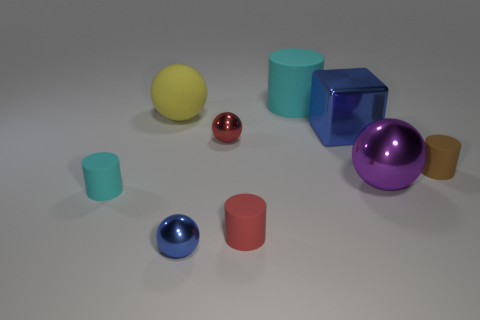Subtract all cylinders. How many objects are left? 5 Subtract 0 gray blocks. How many objects are left? 9 Subtract all big blue objects. Subtract all large cyan rubber cylinders. How many objects are left? 7 Add 4 large yellow rubber balls. How many large yellow rubber balls are left? 5 Add 4 cylinders. How many cylinders exist? 8 